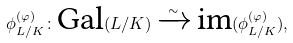Convert formula to latex. <formula><loc_0><loc_0><loc_500><loc_500>\phi _ { L / K } ^ { ( \varphi ) } \colon \text {Gal} ( L / K ) \xrightarrow { \sim } \text {im} ( \phi _ { L / K } ^ { ( \varphi ) } ) ,</formula> 